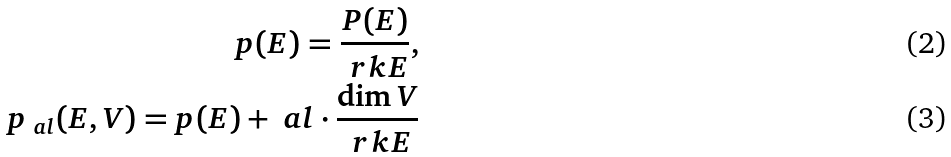<formula> <loc_0><loc_0><loc_500><loc_500>p ( E ) = \frac { P ( E ) } { \ r k E } , \\ p _ { \ a l } ( E , V ) = p ( E ) + \ a l \cdot \frac { \dim V } { \ r k E }</formula> 